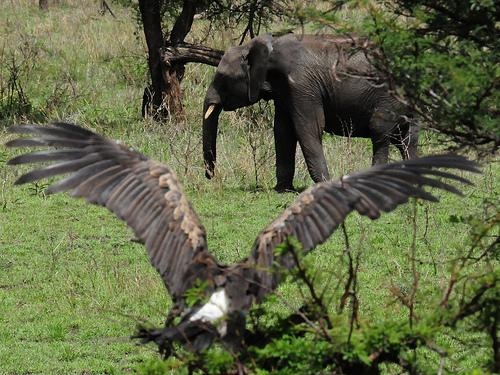What is the primary emotion that the bird is displaying in the image? The bird appears to be cautious or afraid of the elephant, as it has spread out its wings wide and is seemingly preparing for flight. What is the main interaction between the two largest subjects in the image? A bird has spread out its wings, seemingly afraid of the elephant, as they both roam in their natural environment. Is there any noticeable damage to objects in the image? If so, describe it. There is a large tree with a broken branch laying on the ground, surrounded by overgrown brush. Identify one prominent feature of the elephant and describe it. The elephant's tusk is white and protrudes outwards from its face, making it a distinct feature of the mammal. How many animals are there in the image, and which species are they from? There are two animals, one bird, possibly a hawk or predator species, and one elephant. Describe the color and texture of the grass where the animals are located. The grass is green and seems to be tall and high, creating a dense and overgrown environment in the field or clearing. Describe the physical characteristics of the bird in the image. The bird is dark-colored with black feathers, white tail feathers, and a long wingspan with outstretched wings, resembling a predator bird. Examine the physical features of the elephant's skin. The elephant has wrinkled, gray skin providing a textured appearance to the large animal. Mention the type of habitat where the animals are found in the image. The animals are found in a natural environment with tall grass, trees, and bushes, resembling a jungle or wild field. List all the objects you can identify in the image. bird, elephant, tusk, tree, grass, weeds, feathers, bushes, wing, trunk, branches, clearing, skin, tail, jungle, field, broken branch, brush, ear. What color are the weeds in the ground? Brown and white Notice that the bird is carrying a small squirrel in its beak. Since there is no mention of a squirrel or any object (or living thing) being held by the bird within the image, this instruction would confuse the user by suggesting a nonexistent scenario. What type of bird is hunting for prey? A hawk What is the color of the tusk on the elephant? White Observe a monkey swinging on the tree branches next to the hawk. There is no mention of a monkey or any related action in the image information. The instruction creates a misleading situation by implying there is a monkey interactig with other objects. What time of day are the animals out? Daytime What is the state of the tree branch on the ground? Broken Where are the animals enjoying their day? Out in the jungle What is the environment like where the animals are? They are in the jungle with high grass, a tree, and overgrown brush. Which animal is afraid of the other? The bird is afraid of the elephant Does the elephant have a pink ribbon tied on its tail? There is no information about the elephant's tail or any decorative element attached to it. This instruction is misleading by questioning the presence of a detail not provided in the context. Which of these statements best describes the elephant? A) The elephant is small B) The elephant is big C) The elephant is flying B) The elephant is big Describe the appearance of the elephant's skin. The skin is wrinkled and gray. Look at the nest of baby birds hidden among the weeds on the ground. No information about baby birds or a nest is provided in the image details. This instruction misleads the user by describing the presence of additional objects that are not mentioned. Describe the bird's position and action. The bird is in the tree with its wings outstretched, preparing to take off. What is happening with the bushes in the area? There is overgrown brush in the background and foreground. Which animal has outstretched wings? A predator bird Can you see a lion climbing on a tree trunk in the background? A lion is not among the objects described in the image. The instruction is asking the user to find something that isn't present in the given context. What body part of the elephant is long and thick? The trunk Find a giraffe stretching its neck to reach the leaves of a tree. There is no giraffe mentioned or described in the image information. This instruction is misleading as it asks the user to look for an object that doesn't exist in the given context. What is the elephant looking for in the wild? Food What part of the bird is white? The tail and back Describe the appearance of the ground. The ground has green grass, brown and white weeds, and died bushes growing. Identify the colors of the bird's feathers. The bird has white, black, and dark-colored feathers. What animal is in the tree? A bird 